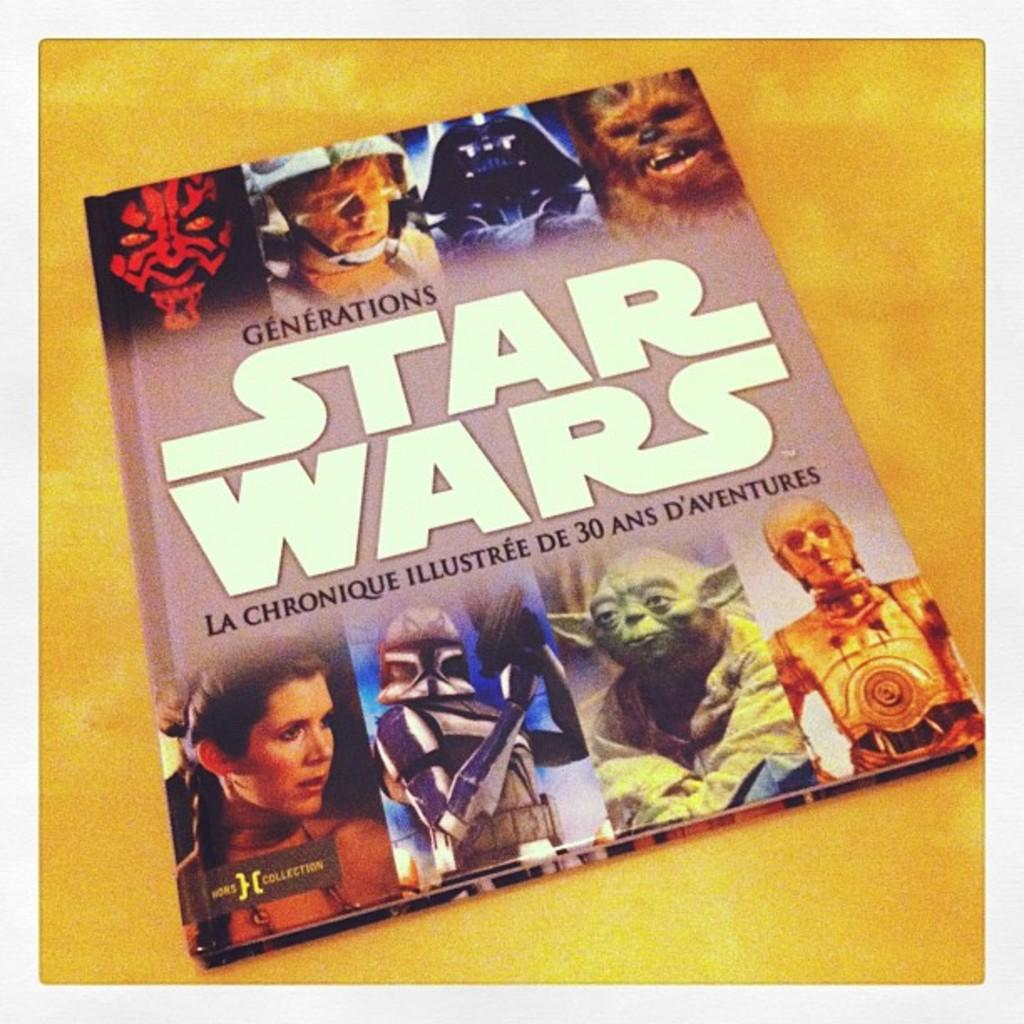What type of publication is visible in the image? There is a magazine in the image. What is the main topic or theme of the magazine? The magazine has "Star Wars" written on it. What color is the surface on which the magazine is placed? The magazine is placed on a yellow surface. How many flowers are arranged around the tank in the image? There is no tank or flowers present in the image; it only features a magazine with "Star Wars" written on it, placed on a yellow surface. 